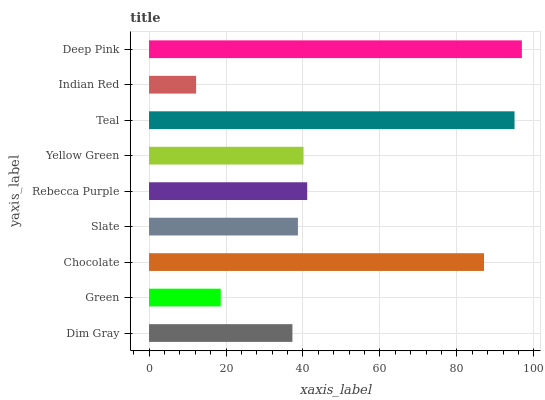Is Indian Red the minimum?
Answer yes or no. Yes. Is Deep Pink the maximum?
Answer yes or no. Yes. Is Green the minimum?
Answer yes or no. No. Is Green the maximum?
Answer yes or no. No. Is Dim Gray greater than Green?
Answer yes or no. Yes. Is Green less than Dim Gray?
Answer yes or no. Yes. Is Green greater than Dim Gray?
Answer yes or no. No. Is Dim Gray less than Green?
Answer yes or no. No. Is Yellow Green the high median?
Answer yes or no. Yes. Is Yellow Green the low median?
Answer yes or no. Yes. Is Indian Red the high median?
Answer yes or no. No. Is Chocolate the low median?
Answer yes or no. No. 